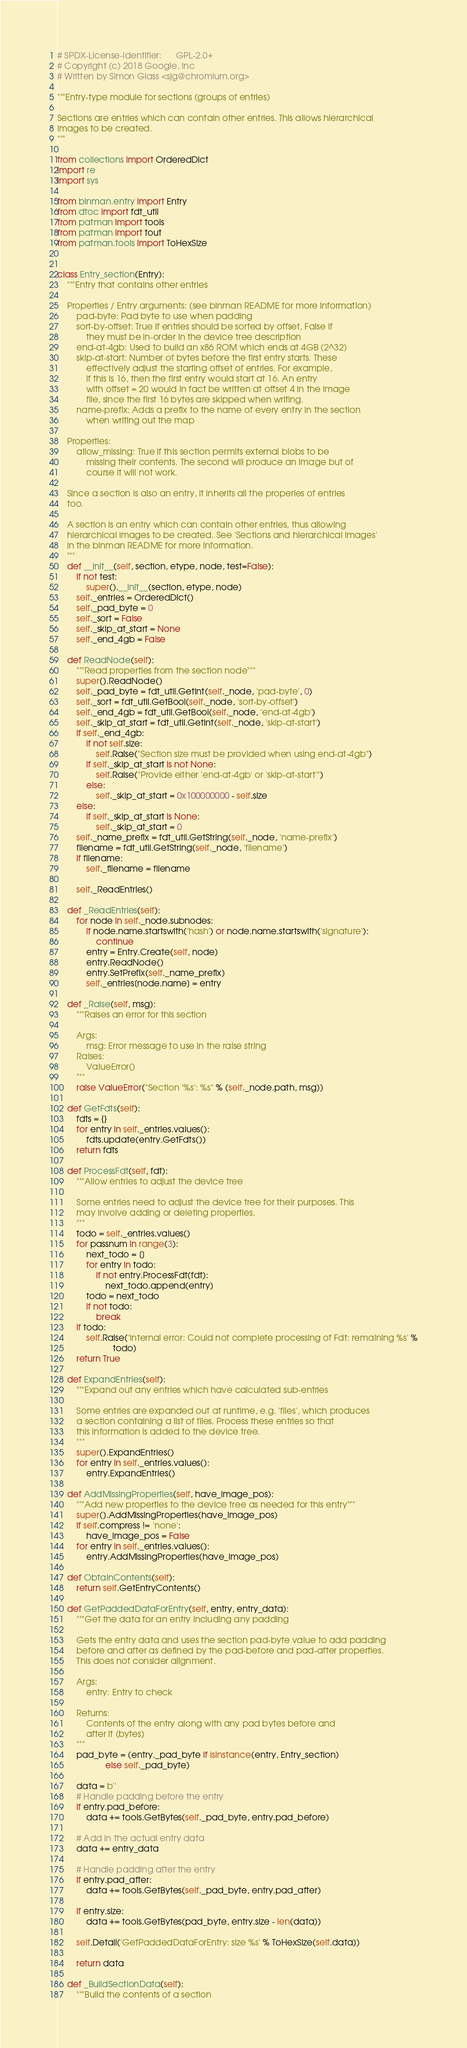<code> <loc_0><loc_0><loc_500><loc_500><_Python_># SPDX-License-Identifier:      GPL-2.0+
# Copyright (c) 2018 Google, Inc
# Written by Simon Glass <sjg@chromium.org>

"""Entry-type module for sections (groups of entries)

Sections are entries which can contain other entries. This allows hierarchical
images to be created.
"""

from collections import OrderedDict
import re
import sys

from binman.entry import Entry
from dtoc import fdt_util
from patman import tools
from patman import tout
from patman.tools import ToHexSize


class Entry_section(Entry):
    """Entry that contains other entries

    Properties / Entry arguments: (see binman README for more information)
        pad-byte: Pad byte to use when padding
        sort-by-offset: True if entries should be sorted by offset, False if
            they must be in-order in the device tree description
        end-at-4gb: Used to build an x86 ROM which ends at 4GB (2^32)
        skip-at-start: Number of bytes before the first entry starts. These
            effectively adjust the starting offset of entries. For example,
            if this is 16, then the first entry would start at 16. An entry
            with offset = 20 would in fact be written at offset 4 in the image
            file, since the first 16 bytes are skipped when writing.
        name-prefix: Adds a prefix to the name of every entry in the section
            when writing out the map

    Properties:
        allow_missing: True if this section permits external blobs to be
            missing their contents. The second will produce an image but of
            course it will not work.

    Since a section is also an entry, it inherits all the properies of entries
    too.

    A section is an entry which can contain other entries, thus allowing
    hierarchical images to be created. See 'Sections and hierarchical images'
    in the binman README for more information.
    """
    def __init__(self, section, etype, node, test=False):
        if not test:
            super().__init__(section, etype, node)
        self._entries = OrderedDict()
        self._pad_byte = 0
        self._sort = False
        self._skip_at_start = None
        self._end_4gb = False

    def ReadNode(self):
        """Read properties from the section node"""
        super().ReadNode()
        self._pad_byte = fdt_util.GetInt(self._node, 'pad-byte', 0)
        self._sort = fdt_util.GetBool(self._node, 'sort-by-offset')
        self._end_4gb = fdt_util.GetBool(self._node, 'end-at-4gb')
        self._skip_at_start = fdt_util.GetInt(self._node, 'skip-at-start')
        if self._end_4gb:
            if not self.size:
                self.Raise("Section size must be provided when using end-at-4gb")
            if self._skip_at_start is not None:
                self.Raise("Provide either 'end-at-4gb' or 'skip-at-start'")
            else:
                self._skip_at_start = 0x100000000 - self.size
        else:
            if self._skip_at_start is None:
                self._skip_at_start = 0
        self._name_prefix = fdt_util.GetString(self._node, 'name-prefix')
        filename = fdt_util.GetString(self._node, 'filename')
        if filename:
            self._filename = filename

        self._ReadEntries()

    def _ReadEntries(self):
        for node in self._node.subnodes:
            if node.name.startswith('hash') or node.name.startswith('signature'):
                continue
            entry = Entry.Create(self, node)
            entry.ReadNode()
            entry.SetPrefix(self._name_prefix)
            self._entries[node.name] = entry

    def _Raise(self, msg):
        """Raises an error for this section

        Args:
            msg: Error message to use in the raise string
        Raises:
            ValueError()
        """
        raise ValueError("Section '%s': %s" % (self._node.path, msg))

    def GetFdts(self):
        fdts = {}
        for entry in self._entries.values():
            fdts.update(entry.GetFdts())
        return fdts

    def ProcessFdt(self, fdt):
        """Allow entries to adjust the device tree

        Some entries need to adjust the device tree for their purposes. This
        may involve adding or deleting properties.
        """
        todo = self._entries.values()
        for passnum in range(3):
            next_todo = []
            for entry in todo:
                if not entry.ProcessFdt(fdt):
                    next_todo.append(entry)
            todo = next_todo
            if not todo:
                break
        if todo:
            self.Raise('Internal error: Could not complete processing of Fdt: remaining %s' %
                       todo)
        return True

    def ExpandEntries(self):
        """Expand out any entries which have calculated sub-entries

        Some entries are expanded out at runtime, e.g. 'files', which produces
        a section containing a list of files. Process these entries so that
        this information is added to the device tree.
        """
        super().ExpandEntries()
        for entry in self._entries.values():
            entry.ExpandEntries()

    def AddMissingProperties(self, have_image_pos):
        """Add new properties to the device tree as needed for this entry"""
        super().AddMissingProperties(have_image_pos)
        if self.compress != 'none':
            have_image_pos = False
        for entry in self._entries.values():
            entry.AddMissingProperties(have_image_pos)

    def ObtainContents(self):
        return self.GetEntryContents()

    def GetPaddedDataForEntry(self, entry, entry_data):
        """Get the data for an entry including any padding

        Gets the entry data and uses the section pad-byte value to add padding
        before and after as defined by the pad-before and pad-after properties.
        This does not consider alignment.

        Args:
            entry: Entry to check

        Returns:
            Contents of the entry along with any pad bytes before and
            after it (bytes)
        """
        pad_byte = (entry._pad_byte if isinstance(entry, Entry_section)
                    else self._pad_byte)

        data = b''
        # Handle padding before the entry
        if entry.pad_before:
            data += tools.GetBytes(self._pad_byte, entry.pad_before)

        # Add in the actual entry data
        data += entry_data

        # Handle padding after the entry
        if entry.pad_after:
            data += tools.GetBytes(self._pad_byte, entry.pad_after)

        if entry.size:
            data += tools.GetBytes(pad_byte, entry.size - len(data))

        self.Detail('GetPaddedDataForEntry: size %s' % ToHexSize(self.data))

        return data

    def _BuildSectionData(self):
        """Build the contents of a section
</code> 